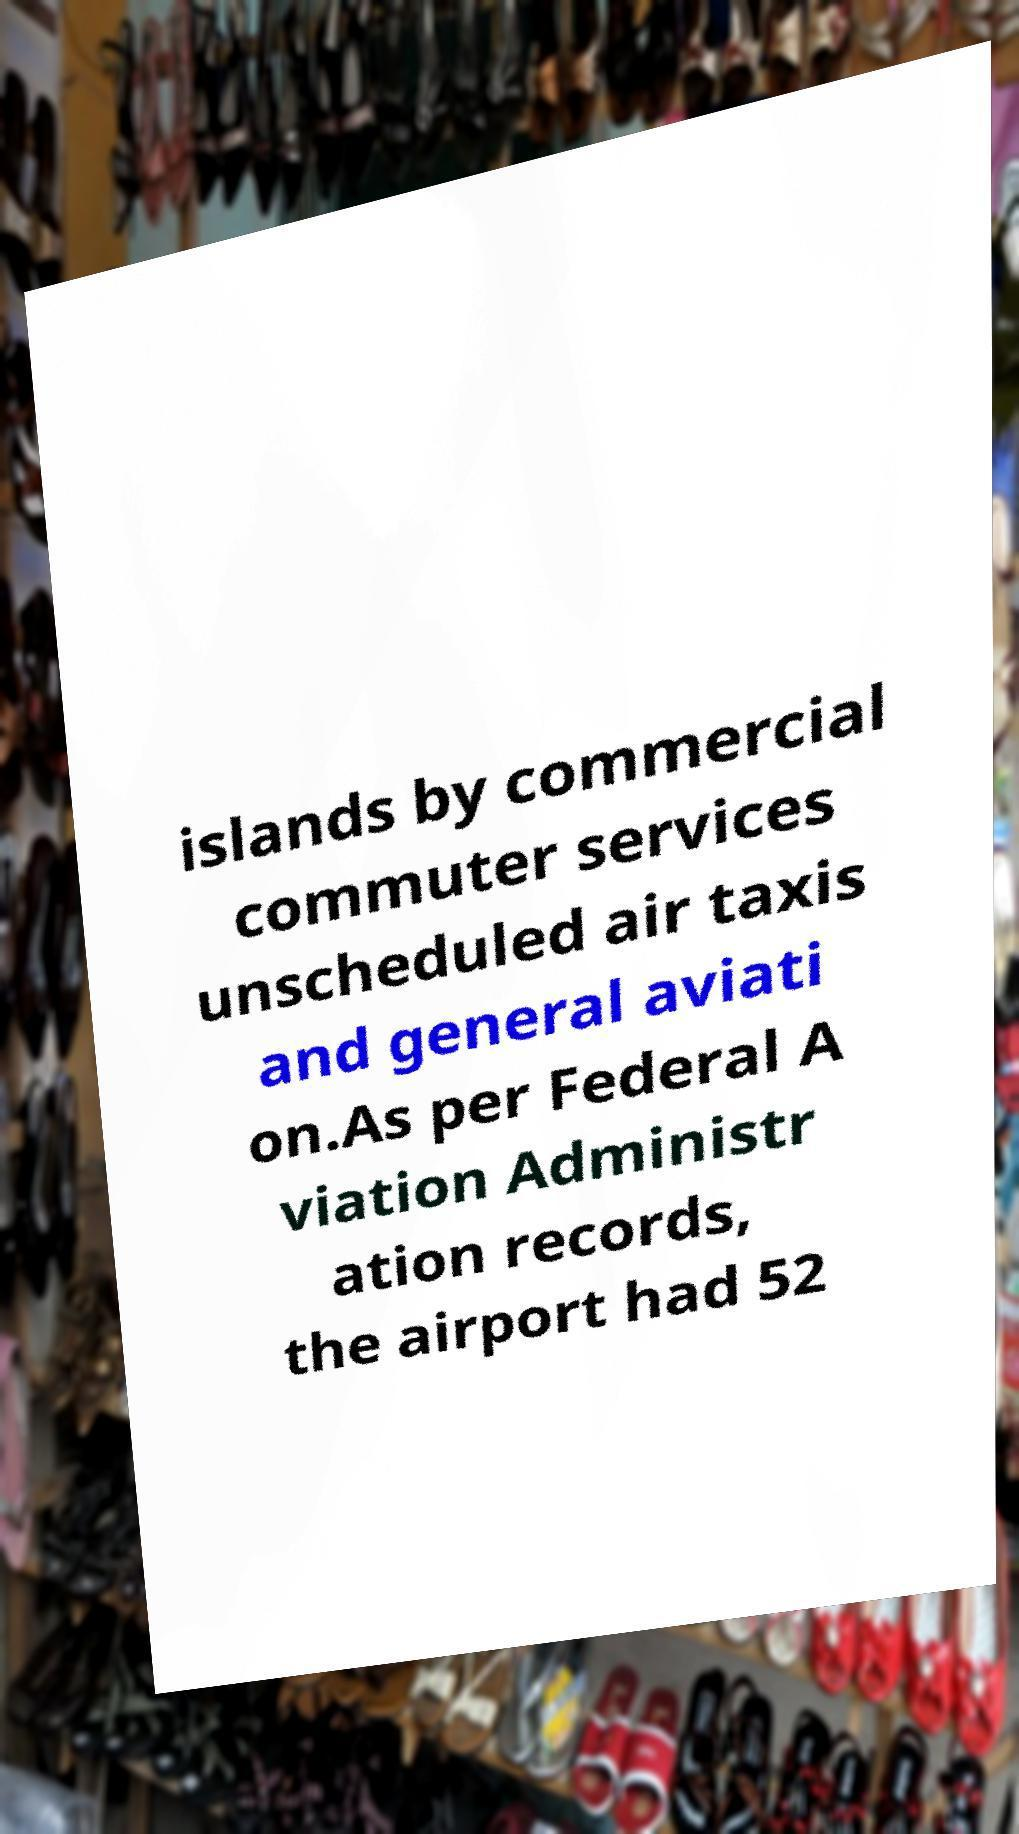I need the written content from this picture converted into text. Can you do that? islands by commercial commuter services unscheduled air taxis and general aviati on.As per Federal A viation Administr ation records, the airport had 52 